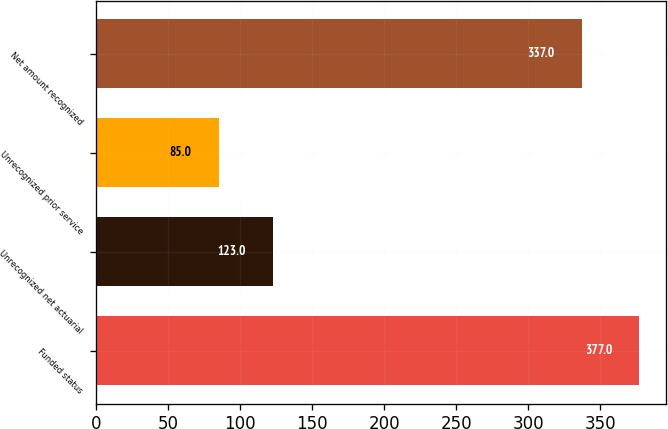Convert chart. <chart><loc_0><loc_0><loc_500><loc_500><bar_chart><fcel>Funded status<fcel>Unrecognized net actuarial<fcel>Unrecognized prior service<fcel>Net amount recognized<nl><fcel>377<fcel>123<fcel>85<fcel>337<nl></chart> 